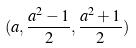Convert formula to latex. <formula><loc_0><loc_0><loc_500><loc_500>( a , \frac { a ^ { 2 } - 1 } { 2 } , \frac { a ^ { 2 } + 1 } { 2 } )</formula> 